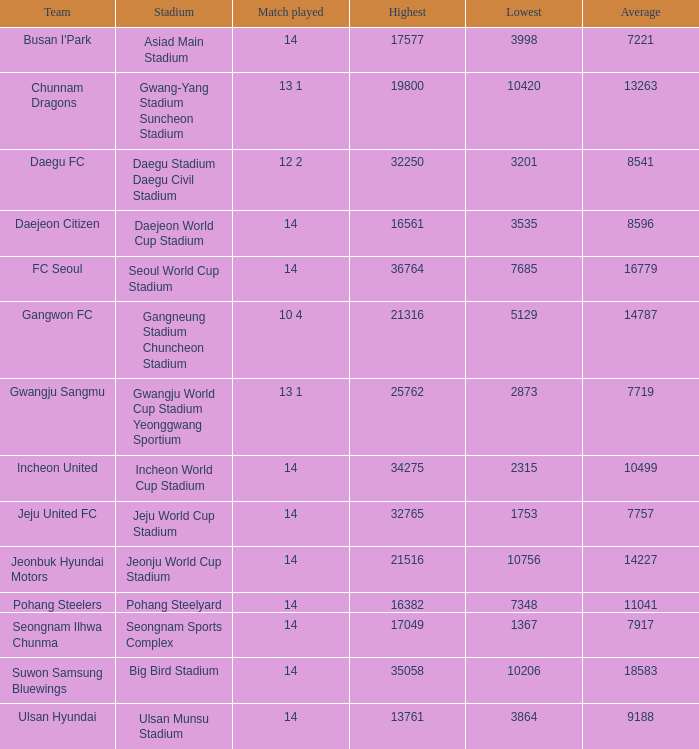What is the peak when pohang steelers is the team? 16382.0. 